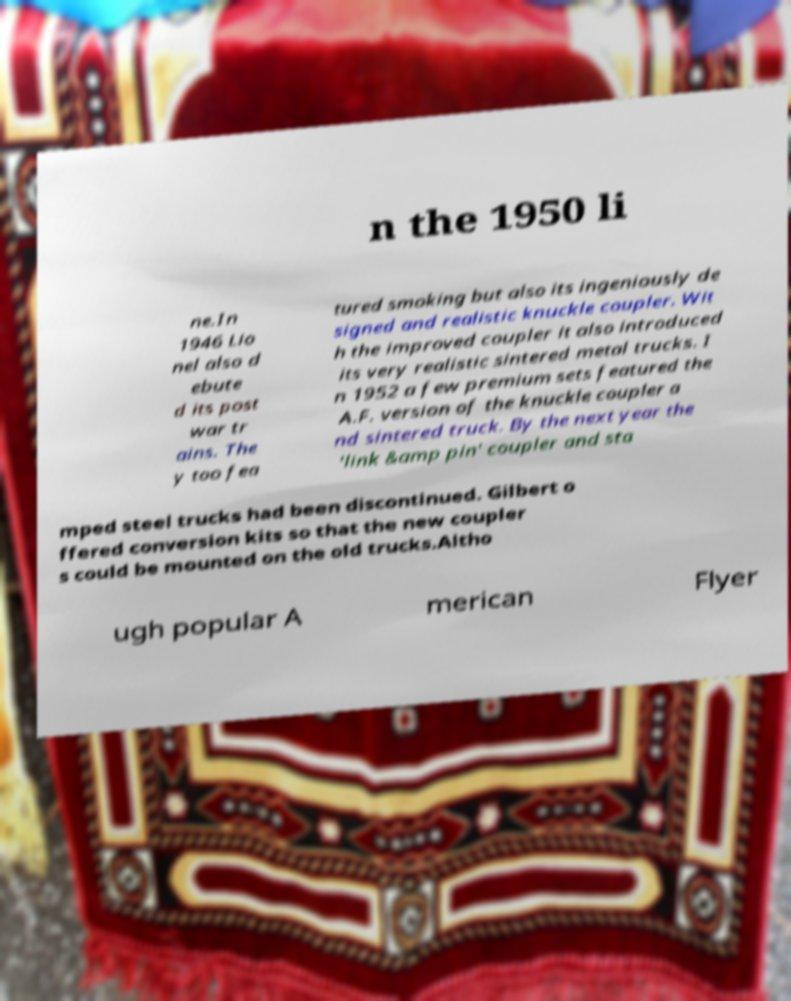Please read and relay the text visible in this image. What does it say? n the 1950 li ne.In 1946 Lio nel also d ebute d its post war tr ains. The y too fea tured smoking but also its ingeniously de signed and realistic knuckle coupler. Wit h the improved coupler it also introduced its very realistic sintered metal trucks. I n 1952 a few premium sets featured the A.F. version of the knuckle coupler a nd sintered truck. By the next year the 'link &amp pin' coupler and sta mped steel trucks had been discontinued. Gilbert o ffered conversion kits so that the new coupler s could be mounted on the old trucks.Altho ugh popular A merican Flyer 